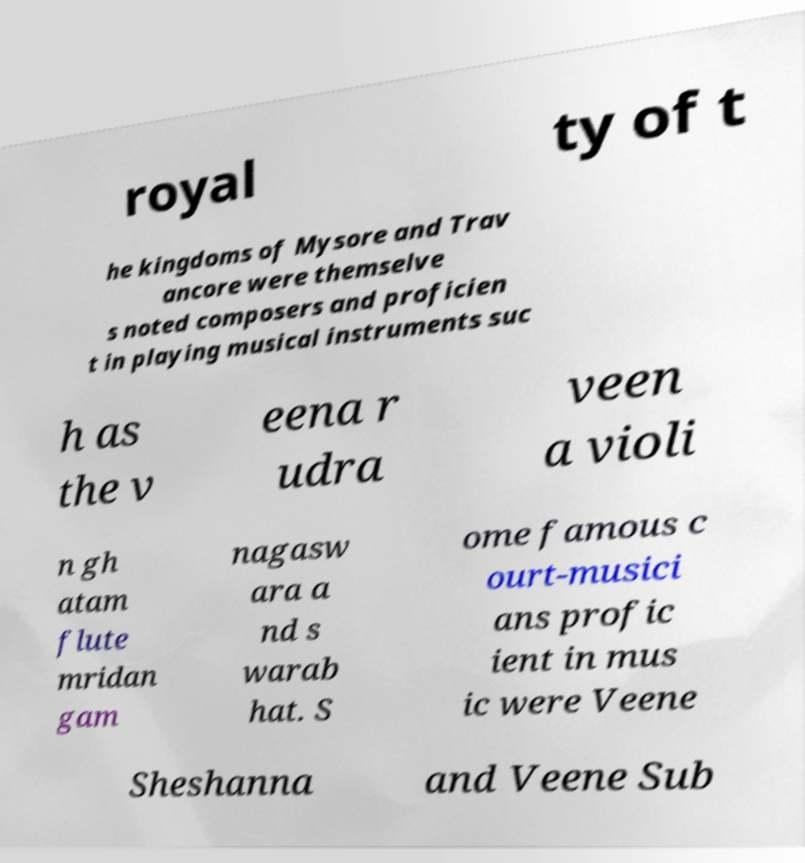Can you accurately transcribe the text from the provided image for me? royal ty of t he kingdoms of Mysore and Trav ancore were themselve s noted composers and proficien t in playing musical instruments suc h as the v eena r udra veen a violi n gh atam flute mridan gam nagasw ara a nd s warab hat. S ome famous c ourt-musici ans profic ient in mus ic were Veene Sheshanna and Veene Sub 